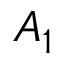<formula> <loc_0><loc_0><loc_500><loc_500>A _ { 1 }</formula> 